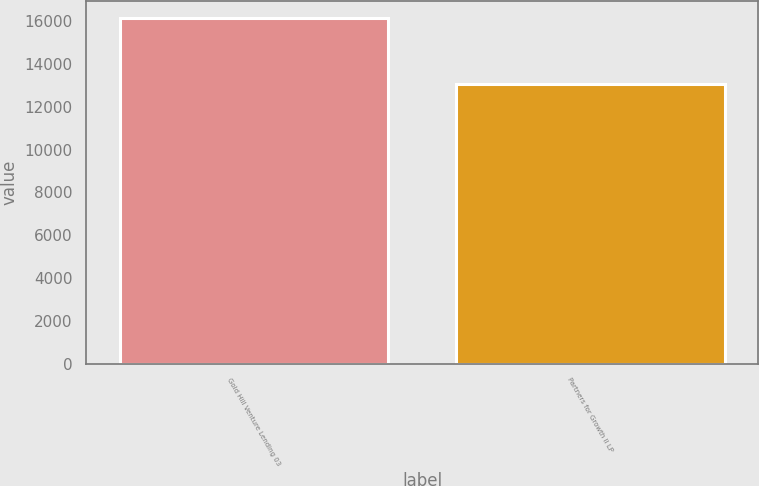Convert chart. <chart><loc_0><loc_0><loc_500><loc_500><bar_chart><fcel>Gold Hill Venture Lending 03<fcel>Partners for Growth II LP<nl><fcel>16134<fcel>13059<nl></chart> 